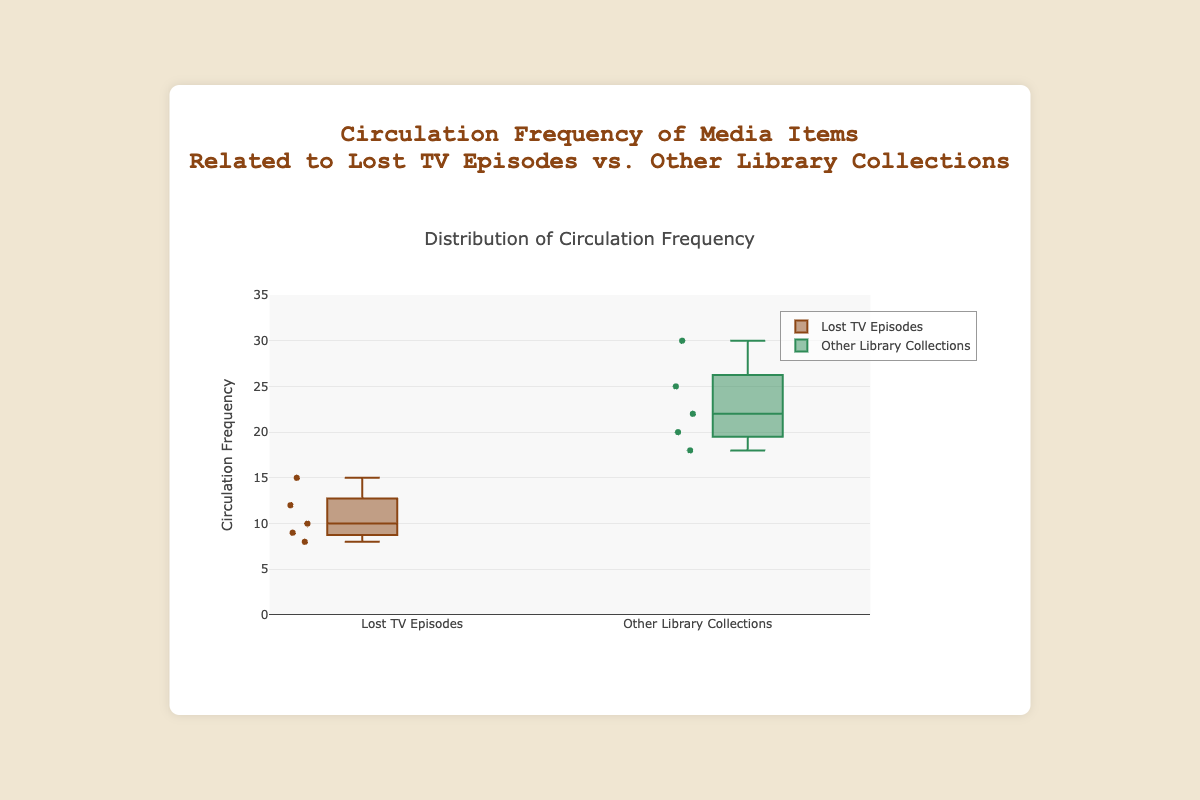what is the title of the plot? The title is located at the top center of the figure, in larger font size, indicating the overall subject of the plot. The title is "Circulation Frequency of Media Items Related to Lost TV Episodes vs. Other Library Collections."
Answer: Circulation Frequency of Media Items Related to Lost TV Episodes vs. Other Library Collections How many data points are within the "Lost TV Episodes" group? In a box plot, individual data points are represented by dots around the box plot. By counting these dots in the "Lost TV Episodes" box plot, we can determine the number of data points.
Answer: 5 What is the highest circulation frequency for "Other Library Collections"? The highest circulation frequency is indicated by the topmost point in the box plot for "Other Library Collections." This point represents the maximum value in the dataset for that category.
Answer: 30 What is the median circulation frequency for "Lost TV Episodes"? The median in a box plot is shown by a line within the box. For "Lost TV Episodes," we locate this line to determine the median value.
Answer: 10 Which group shows a higher median circulation frequency? To compare the median values of two groups, we look at the lines within the boxes for both groups. The higher line indicates the higher median value.
Answer: Other Library Collections Calculate the interquartile range (IQR) for "Other Library Collections." The IQR is the difference between the third quartile (top edge of the box) and the first quartile (bottom edge of the box). To find this, we identify the values at these positions and subtract the first quartile from the third quartile for "Other Library Collections."
Answer: 22 - 20 = 10 Which group has a larger range in circulation frequency? The range is the difference between the maximum and minimum values. We identify the maximum and minimum points for both groups and compare the differences to determine the group with the larger range.
Answer: Other Library Collections Are there any outliers in the "Lost TV Episodes" box plot? Outliers in a box plot are represented by points that fall outside the whiskers (i.e., lines extending from the box). We look for any such points in the "Lost TV Episodes" plot.
Answer: No What is the minimum circulation frequency recorded for "Lost TV Episodes"? The minimum circulation frequency is the lowest point in the box plot for "Lost TV Episodes." This point represents the smallest value within that dataset.
Answer: 8 Compare the upper quartiles of both groups. Which is higher and by how much? The upper quartile is represented by the top edge of the box. We identify these positions for both groups and then calculate the difference between them to determine which is higher and by how much.
Answer: 22 (Other) - 12 (Lost TV) = 10 